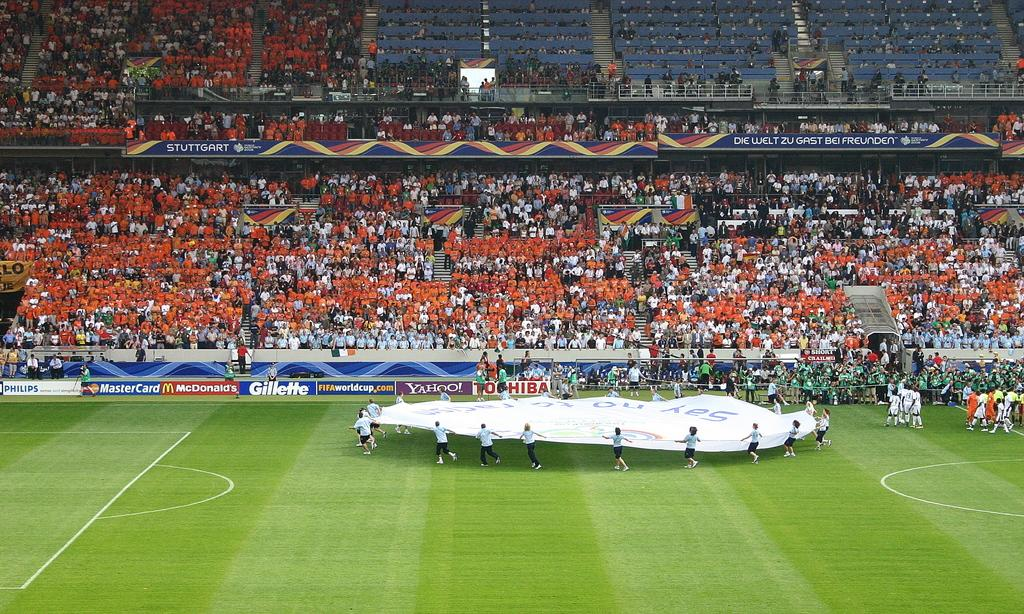<image>
Write a terse but informative summary of the picture. People are carrying a large white sheet onto a field that has McDonalds, Mastercard, and Yahoo banners around it. 